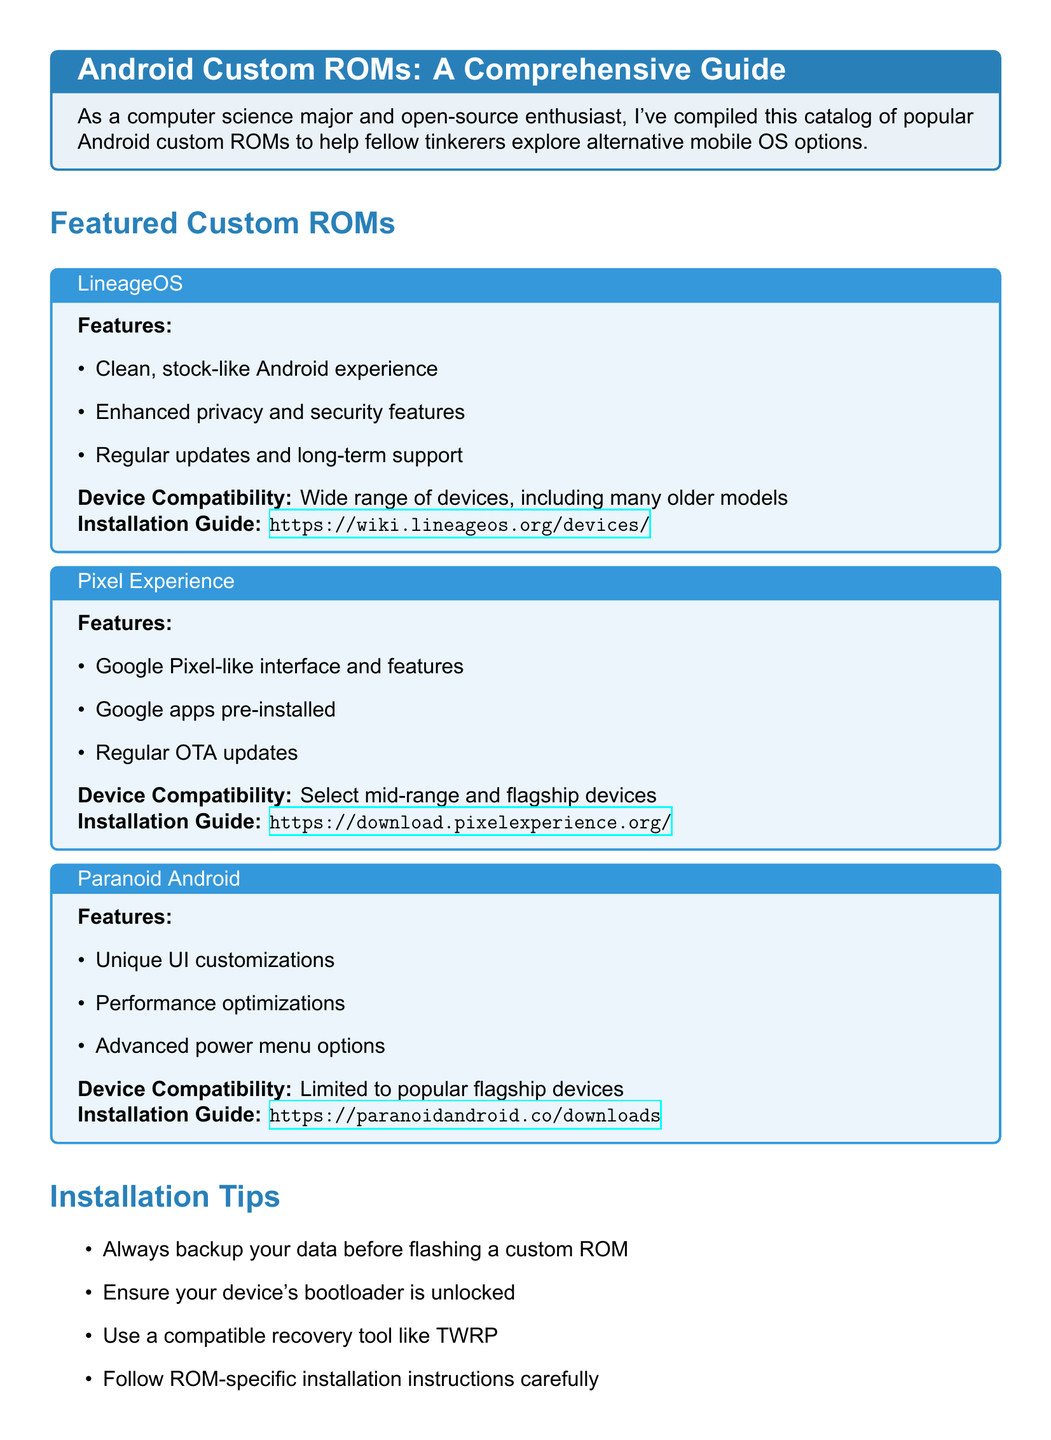What is the first custom ROM listed? The first custom ROM listed in the document is LineageOS.
Answer: LineageOS What feature does Pixel Experience provide? Pixel Experience provides a Google Pixel-like interface and features.
Answer: Google Pixel-like interface How many installation tips are provided? The document contains four installation tips in the tips section.
Answer: Four Which custom ROM is limited to popular flagship devices? The custom ROM that is limited to popular flagship devices is Paranoid Android.
Answer: Paranoid Android Where can installation guides for LineageOS be found? The installation guide for LineageOS can be found at the provided URL in the document.
Answer: https://wiki.lineageos.org/devices/ What is the main focus of the catalog? The main focus of the catalog is to provide information about Android custom ROMs.
Answer: Android custom ROMs Which custom ROM has pre-installed Google apps? The custom ROM that has Google apps pre-installed is Pixel Experience.
Answer: Pixel Experience What is recommended before flashing a custom ROM? It is recommended to always backup your data before flashing a custom ROM.
Answer: Backup your data 